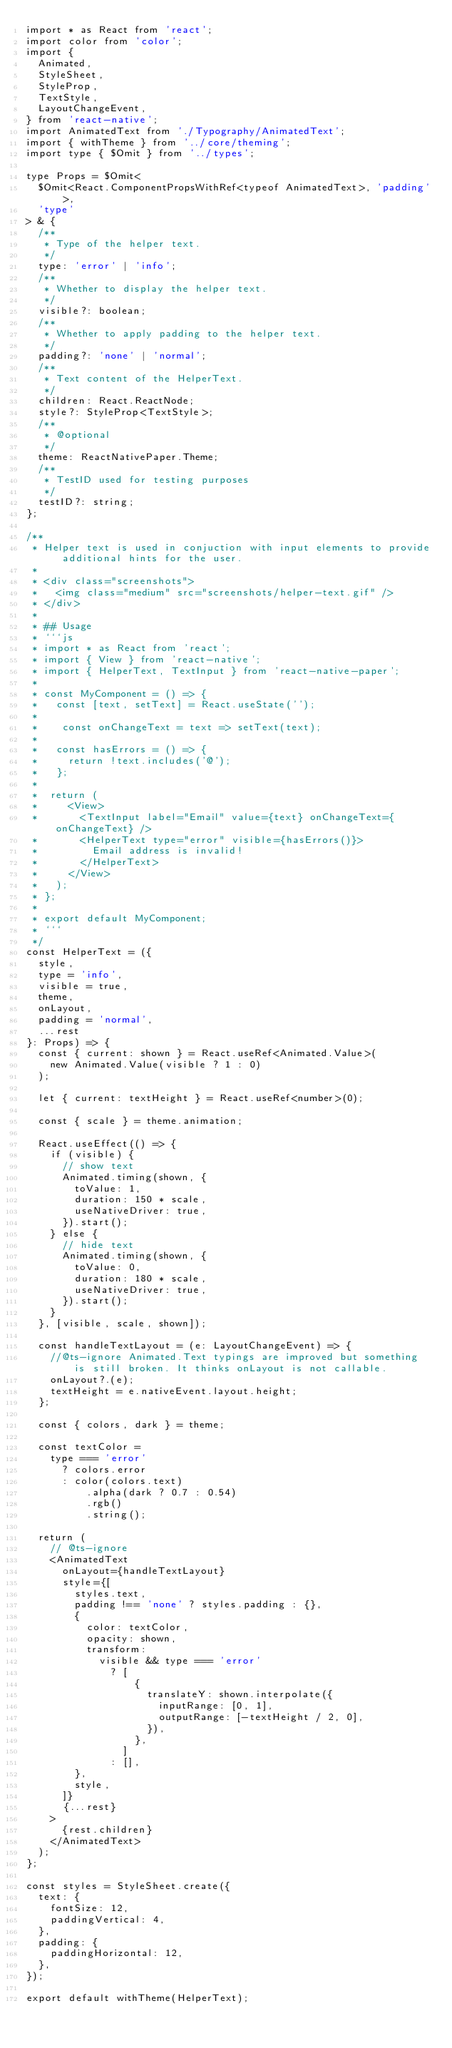Convert code to text. <code><loc_0><loc_0><loc_500><loc_500><_TypeScript_>import * as React from 'react';
import color from 'color';
import {
  Animated,
  StyleSheet,
  StyleProp,
  TextStyle,
  LayoutChangeEvent,
} from 'react-native';
import AnimatedText from './Typography/AnimatedText';
import { withTheme } from '../core/theming';
import type { $Omit } from '../types';

type Props = $Omit<
  $Omit<React.ComponentPropsWithRef<typeof AnimatedText>, 'padding'>,
  'type'
> & {
  /**
   * Type of the helper text.
   */
  type: 'error' | 'info';
  /**
   * Whether to display the helper text.
   */
  visible?: boolean;
  /**
   * Whether to apply padding to the helper text.
   */
  padding?: 'none' | 'normal';
  /**
   * Text content of the HelperText.
   */
  children: React.ReactNode;
  style?: StyleProp<TextStyle>;
  /**
   * @optional
   */
  theme: ReactNativePaper.Theme;
  /**
   * TestID used for testing purposes
   */
  testID?: string;
};

/**
 * Helper text is used in conjuction with input elements to provide additional hints for the user.
 *
 * <div class="screenshots">
 *   <img class="medium" src="screenshots/helper-text.gif" />
 * </div>
 *
 * ## Usage
 * ```js
 * import * as React from 'react';
 * import { View } from 'react-native';
 * import { HelperText, TextInput } from 'react-native-paper';
 *
 * const MyComponent = () => {
 *   const [text, setText] = React.useState('');
 *
 *    const onChangeText = text => setText(text);
 *
 *   const hasErrors = () => {
 *     return !text.includes('@');
 *   };
 *
 *  return (
 *     <View>
 *       <TextInput label="Email" value={text} onChangeText={onChangeText} />
 *       <HelperText type="error" visible={hasErrors()}>
 *         Email address is invalid!
 *       </HelperText>
 *     </View>
 *   );
 * };
 *
 * export default MyComponent;
 * ```
 */
const HelperText = ({
  style,
  type = 'info',
  visible = true,
  theme,
  onLayout,
  padding = 'normal',
  ...rest
}: Props) => {
  const { current: shown } = React.useRef<Animated.Value>(
    new Animated.Value(visible ? 1 : 0)
  );

  let { current: textHeight } = React.useRef<number>(0);

  const { scale } = theme.animation;

  React.useEffect(() => {
    if (visible) {
      // show text
      Animated.timing(shown, {
        toValue: 1,
        duration: 150 * scale,
        useNativeDriver: true,
      }).start();
    } else {
      // hide text
      Animated.timing(shown, {
        toValue: 0,
        duration: 180 * scale,
        useNativeDriver: true,
      }).start();
    }
  }, [visible, scale, shown]);

  const handleTextLayout = (e: LayoutChangeEvent) => {
    //@ts-ignore Animated.Text typings are improved but something is still broken. It thinks onLayout is not callable.
    onLayout?.(e);
    textHeight = e.nativeEvent.layout.height;
  };

  const { colors, dark } = theme;

  const textColor =
    type === 'error'
      ? colors.error
      : color(colors.text)
          .alpha(dark ? 0.7 : 0.54)
          .rgb()
          .string();

  return (
    // @ts-ignore
    <AnimatedText
      onLayout={handleTextLayout}
      style={[
        styles.text,
        padding !== 'none' ? styles.padding : {},
        {
          color: textColor,
          opacity: shown,
          transform:
            visible && type === 'error'
              ? [
                  {
                    translateY: shown.interpolate({
                      inputRange: [0, 1],
                      outputRange: [-textHeight / 2, 0],
                    }),
                  },
                ]
              : [],
        },
        style,
      ]}
      {...rest}
    >
      {rest.children}
    </AnimatedText>
  );
};

const styles = StyleSheet.create({
  text: {
    fontSize: 12,
    paddingVertical: 4,
  },
  padding: {
    paddingHorizontal: 12,
  },
});

export default withTheme(HelperText);
</code> 